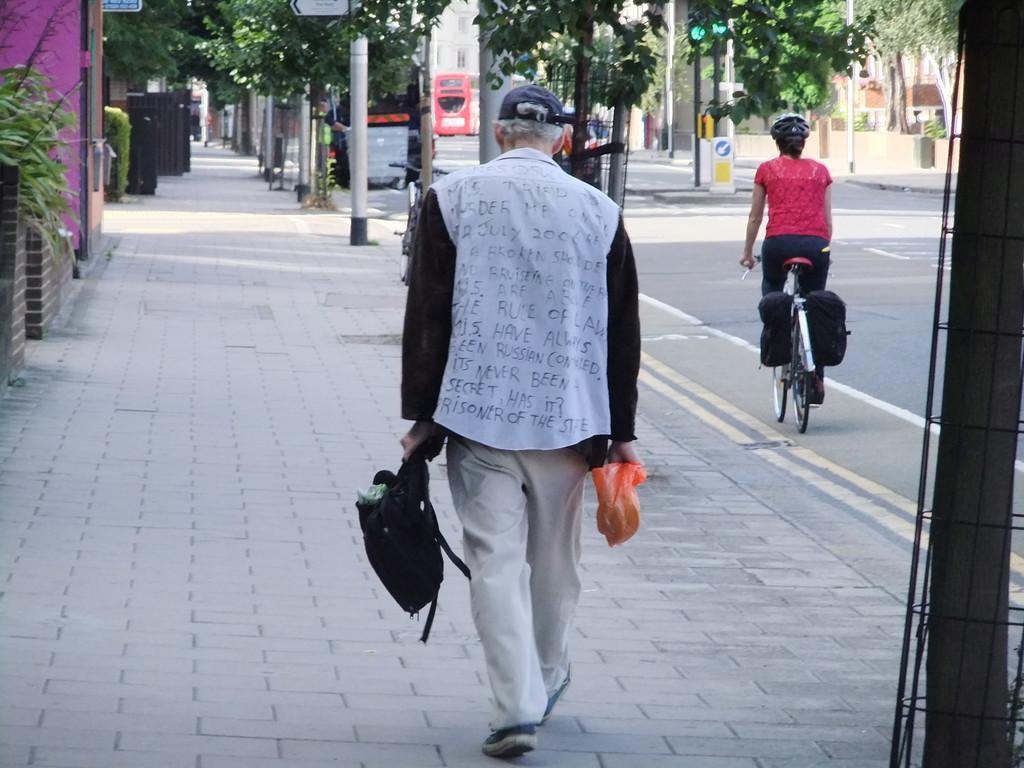Can you describe this image briefly? Picture is taken on the road where two people are there, at the right corner of the picture one woman is riding bicycle in red shirt and person is walking and holding bags in his hands, in front of him there are trees and building. 